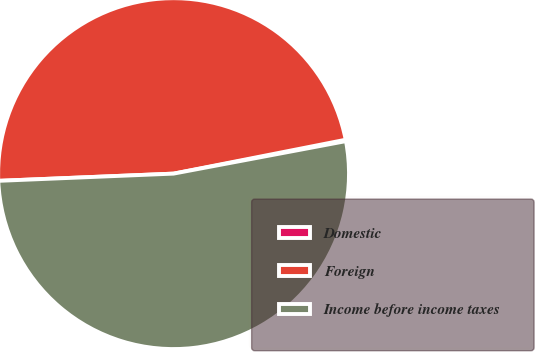<chart> <loc_0><loc_0><loc_500><loc_500><pie_chart><fcel>Domestic<fcel>Foreign<fcel>Income before income taxes<nl><fcel>0.13%<fcel>47.56%<fcel>52.31%<nl></chart> 